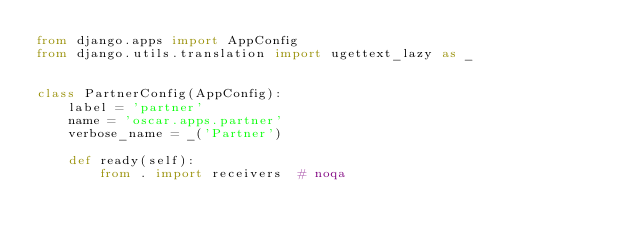<code> <loc_0><loc_0><loc_500><loc_500><_Python_>from django.apps import AppConfig
from django.utils.translation import ugettext_lazy as _


class PartnerConfig(AppConfig):
    label = 'partner'
    name = 'oscar.apps.partner'
    verbose_name = _('Partner')

    def ready(self):
        from . import receivers  # noqa
</code> 